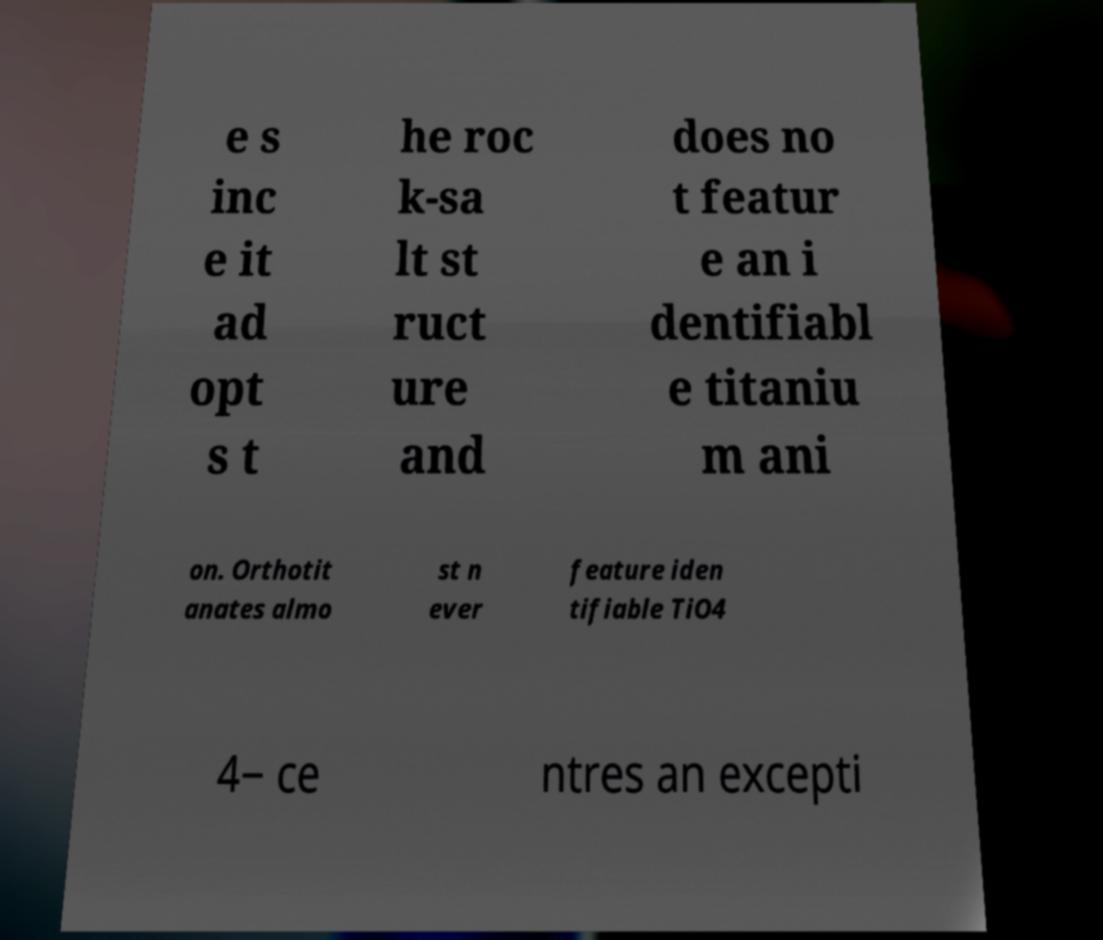Could you assist in decoding the text presented in this image and type it out clearly? e s inc e it ad opt s t he roc k-sa lt st ruct ure and does no t featur e an i dentifiabl e titaniu m ani on. Orthotit anates almo st n ever feature iden tifiable TiO4 4− ce ntres an excepti 